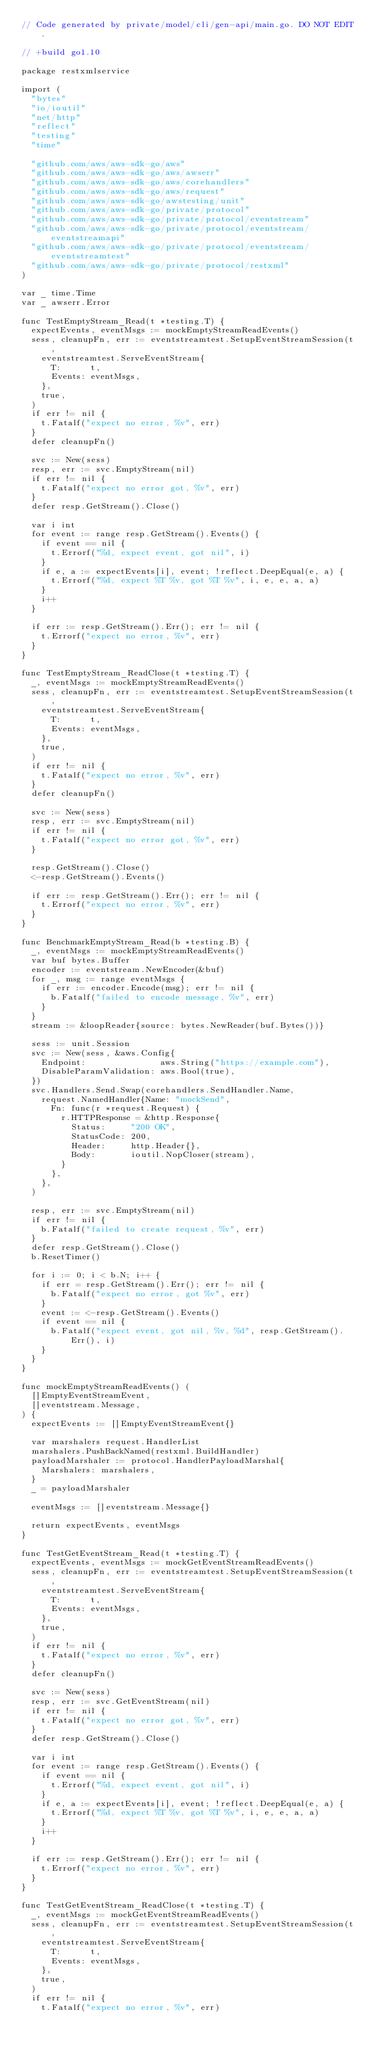Convert code to text. <code><loc_0><loc_0><loc_500><loc_500><_Go_>// Code generated by private/model/cli/gen-api/main.go. DO NOT EDIT.

// +build go1.10

package restxmlservice

import (
	"bytes"
	"io/ioutil"
	"net/http"
	"reflect"
	"testing"
	"time"

	"github.com/aws/aws-sdk-go/aws"
	"github.com/aws/aws-sdk-go/aws/awserr"
	"github.com/aws/aws-sdk-go/aws/corehandlers"
	"github.com/aws/aws-sdk-go/aws/request"
	"github.com/aws/aws-sdk-go/awstesting/unit"
	"github.com/aws/aws-sdk-go/private/protocol"
	"github.com/aws/aws-sdk-go/private/protocol/eventstream"
	"github.com/aws/aws-sdk-go/private/protocol/eventstream/eventstreamapi"
	"github.com/aws/aws-sdk-go/private/protocol/eventstream/eventstreamtest"
	"github.com/aws/aws-sdk-go/private/protocol/restxml"
)

var _ time.Time
var _ awserr.Error

func TestEmptyStream_Read(t *testing.T) {
	expectEvents, eventMsgs := mockEmptyStreamReadEvents()
	sess, cleanupFn, err := eventstreamtest.SetupEventStreamSession(t,
		eventstreamtest.ServeEventStream{
			T:      t,
			Events: eventMsgs,
		},
		true,
	)
	if err != nil {
		t.Fatalf("expect no error, %v", err)
	}
	defer cleanupFn()

	svc := New(sess)
	resp, err := svc.EmptyStream(nil)
	if err != nil {
		t.Fatalf("expect no error got, %v", err)
	}
	defer resp.GetStream().Close()

	var i int
	for event := range resp.GetStream().Events() {
		if event == nil {
			t.Errorf("%d, expect event, got nil", i)
		}
		if e, a := expectEvents[i], event; !reflect.DeepEqual(e, a) {
			t.Errorf("%d, expect %T %v, got %T %v", i, e, e, a, a)
		}
		i++
	}

	if err := resp.GetStream().Err(); err != nil {
		t.Errorf("expect no error, %v", err)
	}
}

func TestEmptyStream_ReadClose(t *testing.T) {
	_, eventMsgs := mockEmptyStreamReadEvents()
	sess, cleanupFn, err := eventstreamtest.SetupEventStreamSession(t,
		eventstreamtest.ServeEventStream{
			T:      t,
			Events: eventMsgs,
		},
		true,
	)
	if err != nil {
		t.Fatalf("expect no error, %v", err)
	}
	defer cleanupFn()

	svc := New(sess)
	resp, err := svc.EmptyStream(nil)
	if err != nil {
		t.Fatalf("expect no error got, %v", err)
	}

	resp.GetStream().Close()
	<-resp.GetStream().Events()

	if err := resp.GetStream().Err(); err != nil {
		t.Errorf("expect no error, %v", err)
	}
}

func BenchmarkEmptyStream_Read(b *testing.B) {
	_, eventMsgs := mockEmptyStreamReadEvents()
	var buf bytes.Buffer
	encoder := eventstream.NewEncoder(&buf)
	for _, msg := range eventMsgs {
		if err := encoder.Encode(msg); err != nil {
			b.Fatalf("failed to encode message, %v", err)
		}
	}
	stream := &loopReader{source: bytes.NewReader(buf.Bytes())}

	sess := unit.Session
	svc := New(sess, &aws.Config{
		Endpoint:               aws.String("https://example.com"),
		DisableParamValidation: aws.Bool(true),
	})
	svc.Handlers.Send.Swap(corehandlers.SendHandler.Name,
		request.NamedHandler{Name: "mockSend",
			Fn: func(r *request.Request) {
				r.HTTPResponse = &http.Response{
					Status:     "200 OK",
					StatusCode: 200,
					Header:     http.Header{},
					Body:       ioutil.NopCloser(stream),
				}
			},
		},
	)

	resp, err := svc.EmptyStream(nil)
	if err != nil {
		b.Fatalf("failed to create request, %v", err)
	}
	defer resp.GetStream().Close()
	b.ResetTimer()

	for i := 0; i < b.N; i++ {
		if err = resp.GetStream().Err(); err != nil {
			b.Fatalf("expect no error, got %v", err)
		}
		event := <-resp.GetStream().Events()
		if event == nil {
			b.Fatalf("expect event, got nil, %v, %d", resp.GetStream().Err(), i)
		}
	}
}

func mockEmptyStreamReadEvents() (
	[]EmptyEventStreamEvent,
	[]eventstream.Message,
) {
	expectEvents := []EmptyEventStreamEvent{}

	var marshalers request.HandlerList
	marshalers.PushBackNamed(restxml.BuildHandler)
	payloadMarshaler := protocol.HandlerPayloadMarshal{
		Marshalers: marshalers,
	}
	_ = payloadMarshaler

	eventMsgs := []eventstream.Message{}

	return expectEvents, eventMsgs
}

func TestGetEventStream_Read(t *testing.T) {
	expectEvents, eventMsgs := mockGetEventStreamReadEvents()
	sess, cleanupFn, err := eventstreamtest.SetupEventStreamSession(t,
		eventstreamtest.ServeEventStream{
			T:      t,
			Events: eventMsgs,
		},
		true,
	)
	if err != nil {
		t.Fatalf("expect no error, %v", err)
	}
	defer cleanupFn()

	svc := New(sess)
	resp, err := svc.GetEventStream(nil)
	if err != nil {
		t.Fatalf("expect no error got, %v", err)
	}
	defer resp.GetStream().Close()

	var i int
	for event := range resp.GetStream().Events() {
		if event == nil {
			t.Errorf("%d, expect event, got nil", i)
		}
		if e, a := expectEvents[i], event; !reflect.DeepEqual(e, a) {
			t.Errorf("%d, expect %T %v, got %T %v", i, e, e, a, a)
		}
		i++
	}

	if err := resp.GetStream().Err(); err != nil {
		t.Errorf("expect no error, %v", err)
	}
}

func TestGetEventStream_ReadClose(t *testing.T) {
	_, eventMsgs := mockGetEventStreamReadEvents()
	sess, cleanupFn, err := eventstreamtest.SetupEventStreamSession(t,
		eventstreamtest.ServeEventStream{
			T:      t,
			Events: eventMsgs,
		},
		true,
	)
	if err != nil {
		t.Fatalf("expect no error, %v", err)</code> 